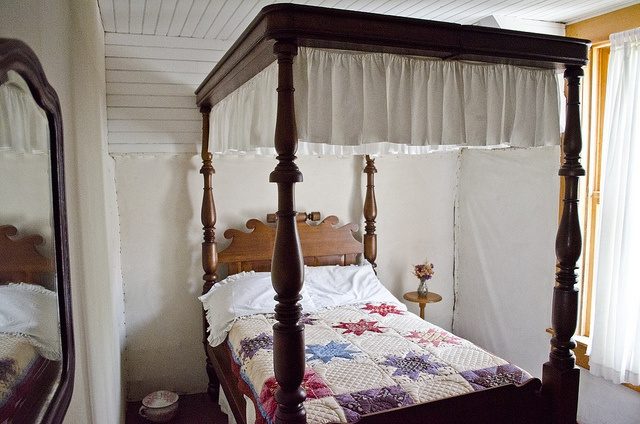Describe the objects in this image and their specific colors. I can see bed in gray, darkgray, black, and lightgray tones, potted plant in gray, darkgray, and maroon tones, and vase in gray, darkgray, and maroon tones in this image. 